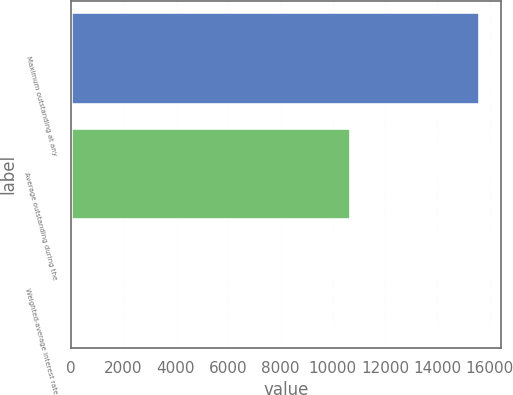Convert chart. <chart><loc_0><loc_0><loc_500><loc_500><bar_chart><fcel>Maximum outstanding at any<fcel>Average outstanding during the<fcel>Weighted-average interest rate<nl><fcel>15645<fcel>10691<fcel>1.26<nl></chart> 